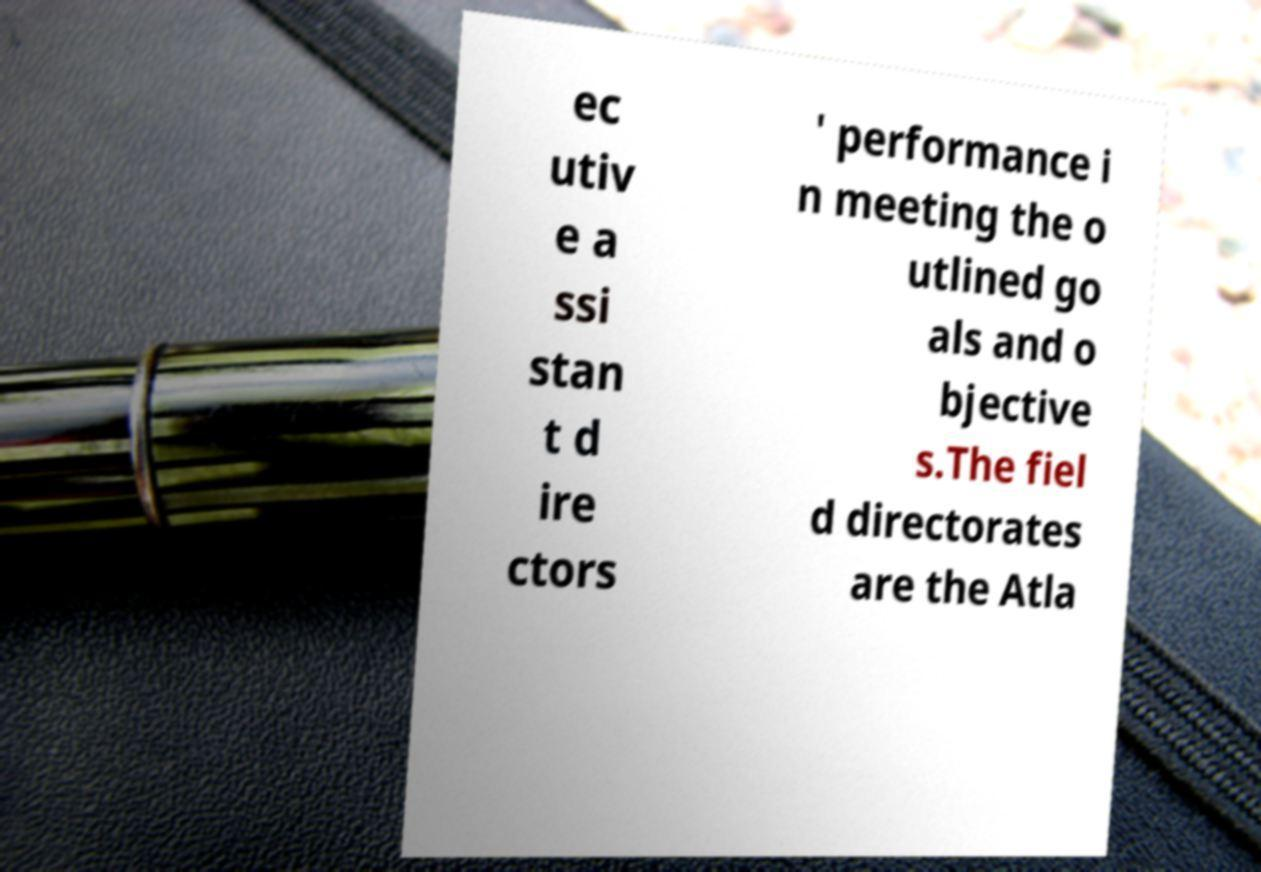Could you extract and type out the text from this image? ec utiv e a ssi stan t d ire ctors ' performance i n meeting the o utlined go als and o bjective s.The fiel d directorates are the Atla 